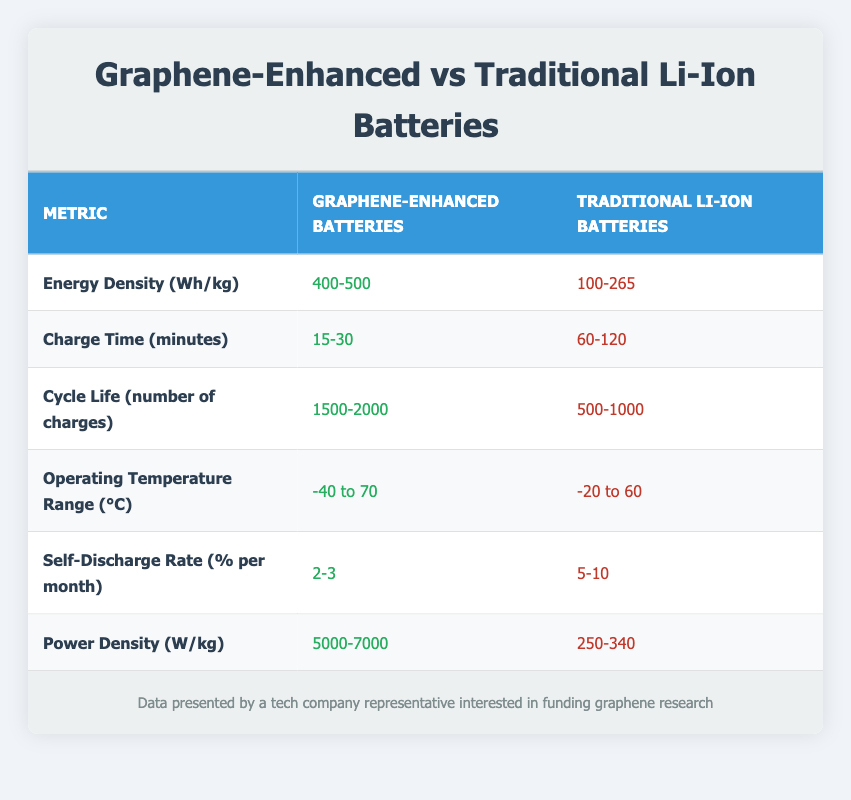What is the energy density of graphene-enhanced batteries? The value for the energy density of graphene-enhanced batteries is provided directly in the table under the corresponding column. It states that the energy density is between 400-500 Wh/kg.
Answer: 400-500 Wh/kg How many charges can graphene-enhanced batteries typically cycle through compared to traditional lithium-ion batteries? The table shows that graphene-enhanced batteries can cycle through 1500-2000 charges, while traditional lithium-ion batteries cycle through 500-1000 charges. To compare, graphene-enhanced batteries have a higher cycle life by at least 1000 charges.
Answer: Higher by 1000 charges Is the self-discharge rate of graphene-enhanced batteries lower than that of traditional lithium-ion batteries? According to the table, the self-discharge rate for graphene-enhanced batteries is 2-3% per month, whereas for traditional lithium-ion batteries, it is 5-10% per month. Since 2-3% is less than 5-10%, the statement is true.
Answer: Yes What is the average charge time for traditional lithium-ion batteries? From the table, the charge time for traditional lithium-ion batteries ranges from 60 to 120 minutes. To find the average, we sum these two values: 60 + 120 = 180, and then divide by 2. The average charge time is 180/2 = 90 minutes.
Answer: 90 minutes Which battery type operates at a wider temperature range? Reviewing the temperature ranges in the table, graphene-enhanced batteries operate from -40 to 70°C, while traditional lithium-ion batteries operate from -20 to 60°C. Since graphene-enhanced batteries operate at a lower minimum and higher maximum, they have a wider operating range.
Answer: Graphene-enhanced batteries How much more power density do graphene-enhanced batteries have compared to traditional lithium-ion batteries? The table indicates that graphene-enhanced batteries have a power density of 5000-7000 W/kg while traditional lithium-ion batteries range from 250-340 W/kg. To find the difference, we can subtract the maximum for lithium-ion from the minimum for graphene. The difference is calculated as 5000 - 340 = 4660. The minimum difference is 4660 W/kg.
Answer: 4660 W/kg What is the range of energy density for traditional lithium-ion batteries? The energy density value for traditional lithium-ion batteries is specified in the table as ranging from 100 to 265 Wh/kg. This range indicates the total span of energy capacity for this battery type.
Answer: 100-265 Wh/kg Do graphene-enhanced batteries take longer to charge than traditional lithium-ion batteries? The charging times for graphene-enhanced batteries are between 15 to 30 minutes, while traditional lithium-ion batteries take 60 to 120 minutes. Since both ranges indicate less time for graphene-enhanced batteries, the statement is false.
Answer: No What is the maximum cycle life for graphene-enhanced batteries? The maximum cycle life for graphene-enhanced batteries is listed in the table as 2000 charges. This value provides the upper limit of how many times these batteries can be charged before their performance degrades significantly.
Answer: 2000 charges 